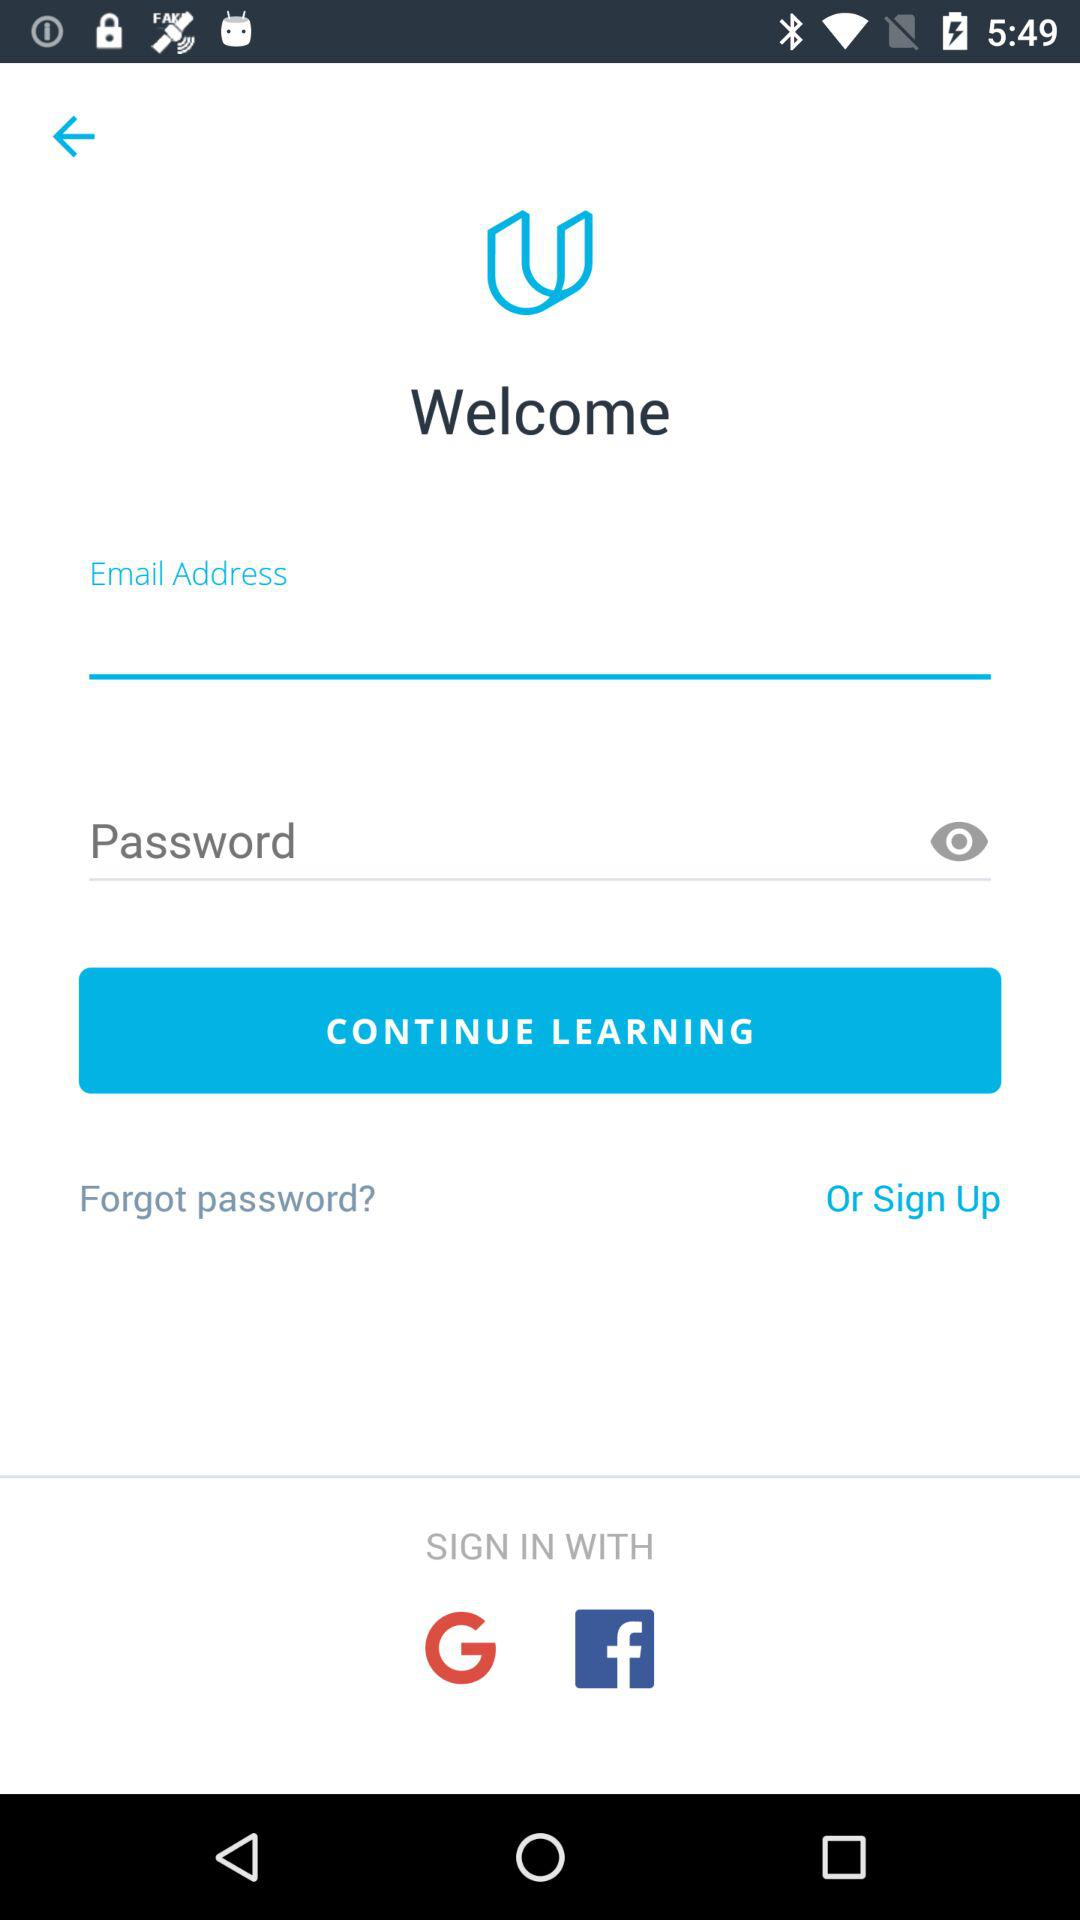How many inputs are there for signing in?
Answer the question using a single word or phrase. 2 